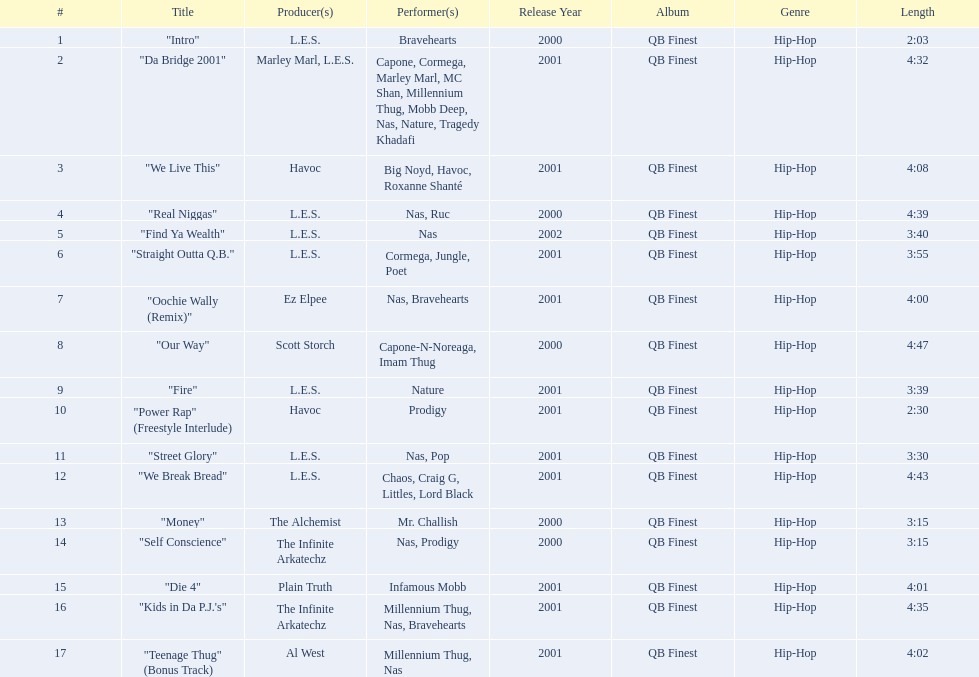What are the track times on the nas & ill will records presents qb's finest album? 2:03, 4:32, 4:08, 4:39, 3:40, 3:55, 4:00, 4:47, 3:39, 2:30, 3:30, 4:43, 3:15, 3:15, 4:01, 4:35, 4:02. Of those which is the longest? 4:47. 